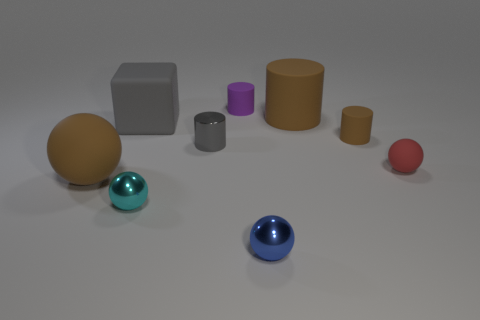Subtract all cubes. How many objects are left? 8 Subtract all small gray metal cylinders. Subtract all small brown matte objects. How many objects are left? 7 Add 1 big gray rubber blocks. How many big gray rubber blocks are left? 2 Add 8 tiny brown matte cylinders. How many tiny brown matte cylinders exist? 9 Subtract 1 brown balls. How many objects are left? 8 